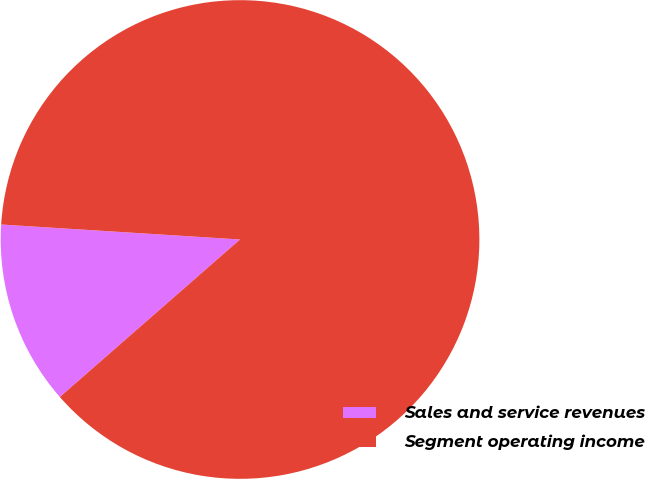<chart> <loc_0><loc_0><loc_500><loc_500><pie_chart><fcel>Sales and service revenues<fcel>Segment operating income<nl><fcel>12.43%<fcel>87.57%<nl></chart> 